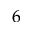<formula> <loc_0><loc_0><loc_500><loc_500>6</formula> 